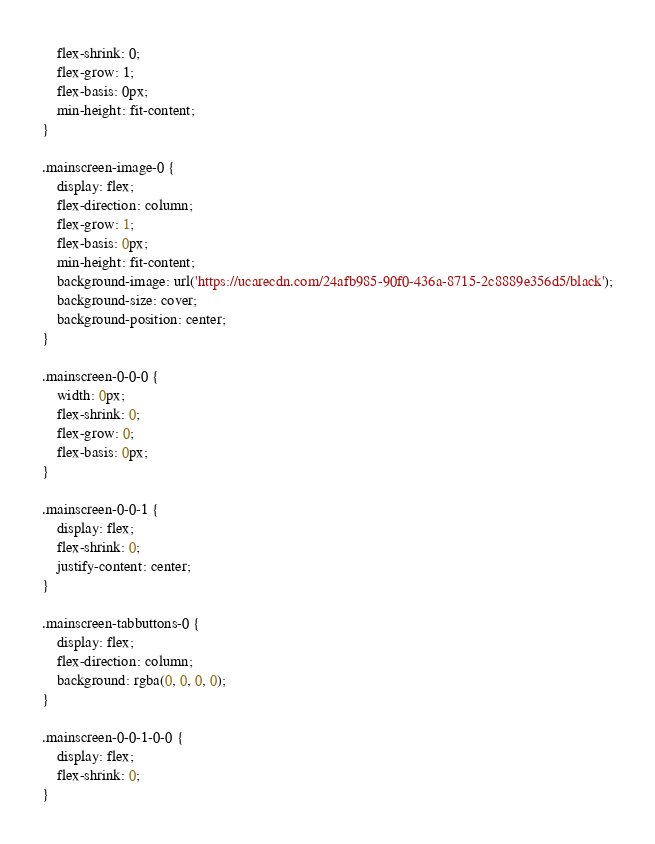<code> <loc_0><loc_0><loc_500><loc_500><_CSS_>    flex-shrink: 0;
    flex-grow: 1;
    flex-basis: 0px;
    min-height: fit-content;
}

.mainscreen-image-0 {
    display: flex;
    flex-direction: column;
    flex-grow: 1;
    flex-basis: 0px;
    min-height: fit-content;
    background-image: url('https://ucarecdn.com/24afb985-90f0-436a-8715-2c8889e356d5/black');
    background-size: cover;
    background-position: center;
}

.mainscreen-0-0-0 {
    width: 0px;
    flex-shrink: 0;
    flex-grow: 0;
    flex-basis: 0px;
}

.mainscreen-0-0-1 {
    display: flex;
    flex-shrink: 0;
    justify-content: center;
}

.mainscreen-tabbuttons-0 {
    display: flex;
    flex-direction: column;
    background: rgba(0, 0, 0, 0);
}

.mainscreen-0-0-1-0-0 {
    display: flex;
    flex-shrink: 0;
}
</code> 